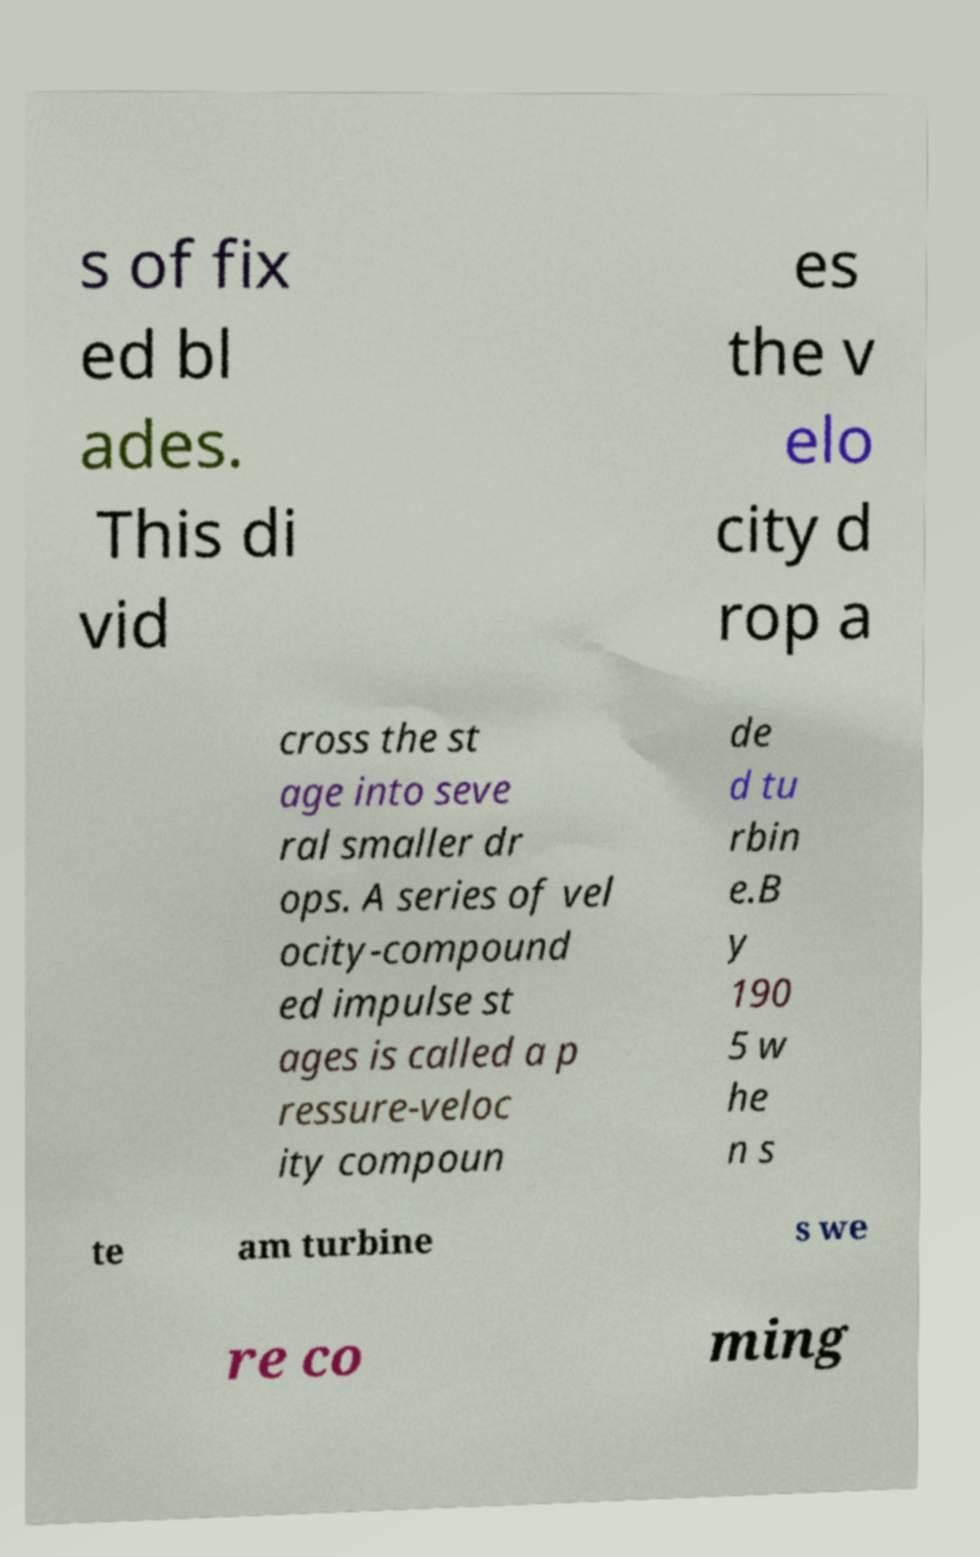Can you read and provide the text displayed in the image?This photo seems to have some interesting text. Can you extract and type it out for me? s of fix ed bl ades. This di vid es the v elo city d rop a cross the st age into seve ral smaller dr ops. A series of vel ocity-compound ed impulse st ages is called a p ressure-veloc ity compoun de d tu rbin e.B y 190 5 w he n s te am turbine s we re co ming 